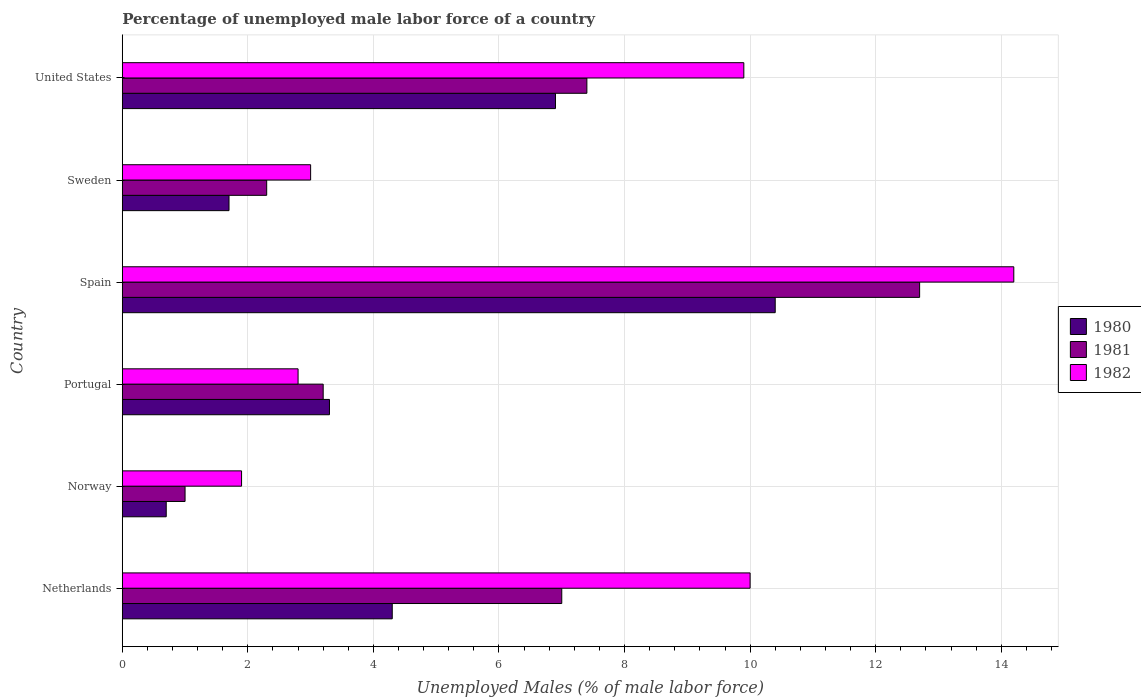How many different coloured bars are there?
Provide a succinct answer. 3. How many groups of bars are there?
Give a very brief answer. 6. Are the number of bars per tick equal to the number of legend labels?
Ensure brevity in your answer.  Yes. What is the percentage of unemployed male labor force in 1981 in Norway?
Ensure brevity in your answer.  1. Across all countries, what is the maximum percentage of unemployed male labor force in 1981?
Offer a very short reply. 12.7. Across all countries, what is the minimum percentage of unemployed male labor force in 1982?
Provide a succinct answer. 1.9. In which country was the percentage of unemployed male labor force in 1980 maximum?
Your response must be concise. Spain. What is the total percentage of unemployed male labor force in 1982 in the graph?
Your response must be concise. 41.8. What is the difference between the percentage of unemployed male labor force in 1980 in Netherlands and that in United States?
Give a very brief answer. -2.6. What is the difference between the percentage of unemployed male labor force in 1982 in Netherlands and the percentage of unemployed male labor force in 1981 in United States?
Your response must be concise. 2.6. What is the average percentage of unemployed male labor force in 1982 per country?
Provide a short and direct response. 6.97. What is the difference between the percentage of unemployed male labor force in 1981 and percentage of unemployed male labor force in 1980 in Spain?
Your answer should be very brief. 2.3. In how many countries, is the percentage of unemployed male labor force in 1982 greater than 10 %?
Your answer should be compact. 1. What is the ratio of the percentage of unemployed male labor force in 1981 in Netherlands to that in Portugal?
Provide a succinct answer. 2.19. Is the percentage of unemployed male labor force in 1980 in Netherlands less than that in United States?
Your response must be concise. Yes. Is the difference between the percentage of unemployed male labor force in 1981 in Netherlands and Portugal greater than the difference between the percentage of unemployed male labor force in 1980 in Netherlands and Portugal?
Keep it short and to the point. Yes. What is the difference between the highest and the second highest percentage of unemployed male labor force in 1982?
Ensure brevity in your answer.  4.2. What is the difference between the highest and the lowest percentage of unemployed male labor force in 1982?
Offer a terse response. 12.3. Is the sum of the percentage of unemployed male labor force in 1981 in Netherlands and United States greater than the maximum percentage of unemployed male labor force in 1982 across all countries?
Give a very brief answer. Yes. Is it the case that in every country, the sum of the percentage of unemployed male labor force in 1981 and percentage of unemployed male labor force in 1980 is greater than the percentage of unemployed male labor force in 1982?
Make the answer very short. No. How many bars are there?
Give a very brief answer. 18. How many countries are there in the graph?
Offer a terse response. 6. Does the graph contain any zero values?
Make the answer very short. No. Where does the legend appear in the graph?
Make the answer very short. Center right. How many legend labels are there?
Your response must be concise. 3. What is the title of the graph?
Provide a short and direct response. Percentage of unemployed male labor force of a country. Does "1990" appear as one of the legend labels in the graph?
Give a very brief answer. No. What is the label or title of the X-axis?
Your answer should be very brief. Unemployed Males (% of male labor force). What is the label or title of the Y-axis?
Your answer should be compact. Country. What is the Unemployed Males (% of male labor force) of 1980 in Netherlands?
Offer a terse response. 4.3. What is the Unemployed Males (% of male labor force) in 1981 in Netherlands?
Give a very brief answer. 7. What is the Unemployed Males (% of male labor force) in 1982 in Netherlands?
Your answer should be compact. 10. What is the Unemployed Males (% of male labor force) in 1980 in Norway?
Make the answer very short. 0.7. What is the Unemployed Males (% of male labor force) of 1982 in Norway?
Ensure brevity in your answer.  1.9. What is the Unemployed Males (% of male labor force) of 1980 in Portugal?
Provide a short and direct response. 3.3. What is the Unemployed Males (% of male labor force) of 1981 in Portugal?
Your answer should be compact. 3.2. What is the Unemployed Males (% of male labor force) in 1982 in Portugal?
Make the answer very short. 2.8. What is the Unemployed Males (% of male labor force) of 1980 in Spain?
Make the answer very short. 10.4. What is the Unemployed Males (% of male labor force) in 1981 in Spain?
Ensure brevity in your answer.  12.7. What is the Unemployed Males (% of male labor force) in 1982 in Spain?
Provide a short and direct response. 14.2. What is the Unemployed Males (% of male labor force) in 1980 in Sweden?
Keep it short and to the point. 1.7. What is the Unemployed Males (% of male labor force) in 1981 in Sweden?
Offer a terse response. 2.3. What is the Unemployed Males (% of male labor force) in 1982 in Sweden?
Provide a short and direct response. 3. What is the Unemployed Males (% of male labor force) in 1980 in United States?
Provide a short and direct response. 6.9. What is the Unemployed Males (% of male labor force) of 1981 in United States?
Make the answer very short. 7.4. What is the Unemployed Males (% of male labor force) of 1982 in United States?
Offer a very short reply. 9.9. Across all countries, what is the maximum Unemployed Males (% of male labor force) in 1980?
Offer a very short reply. 10.4. Across all countries, what is the maximum Unemployed Males (% of male labor force) of 1981?
Provide a short and direct response. 12.7. Across all countries, what is the maximum Unemployed Males (% of male labor force) of 1982?
Your answer should be compact. 14.2. Across all countries, what is the minimum Unemployed Males (% of male labor force) of 1980?
Your answer should be very brief. 0.7. Across all countries, what is the minimum Unemployed Males (% of male labor force) in 1982?
Your response must be concise. 1.9. What is the total Unemployed Males (% of male labor force) in 1980 in the graph?
Your answer should be very brief. 27.3. What is the total Unemployed Males (% of male labor force) in 1981 in the graph?
Keep it short and to the point. 33.6. What is the total Unemployed Males (% of male labor force) of 1982 in the graph?
Ensure brevity in your answer.  41.8. What is the difference between the Unemployed Males (% of male labor force) of 1982 in Netherlands and that in Portugal?
Your answer should be compact. 7.2. What is the difference between the Unemployed Males (% of male labor force) in 1980 in Netherlands and that in United States?
Provide a short and direct response. -2.6. What is the difference between the Unemployed Males (% of male labor force) of 1982 in Netherlands and that in United States?
Your answer should be very brief. 0.1. What is the difference between the Unemployed Males (% of male labor force) of 1980 in Norway and that in Portugal?
Provide a succinct answer. -2.6. What is the difference between the Unemployed Males (% of male labor force) of 1981 in Norway and that in Portugal?
Offer a very short reply. -2.2. What is the difference between the Unemployed Males (% of male labor force) of 1982 in Norway and that in Portugal?
Make the answer very short. -0.9. What is the difference between the Unemployed Males (% of male labor force) of 1982 in Norway and that in Spain?
Offer a terse response. -12.3. What is the difference between the Unemployed Males (% of male labor force) of 1980 in Norway and that in Sweden?
Keep it short and to the point. -1. What is the difference between the Unemployed Males (% of male labor force) in 1980 in Norway and that in United States?
Provide a short and direct response. -6.2. What is the difference between the Unemployed Males (% of male labor force) in 1981 in Norway and that in United States?
Keep it short and to the point. -6.4. What is the difference between the Unemployed Males (% of male labor force) of 1982 in Portugal and that in Spain?
Give a very brief answer. -11.4. What is the difference between the Unemployed Males (% of male labor force) in 1980 in Portugal and that in Sweden?
Your answer should be compact. 1.6. What is the difference between the Unemployed Males (% of male labor force) of 1982 in Portugal and that in Sweden?
Provide a short and direct response. -0.2. What is the difference between the Unemployed Males (% of male labor force) of 1980 in Portugal and that in United States?
Provide a short and direct response. -3.6. What is the difference between the Unemployed Males (% of male labor force) in 1981 in Portugal and that in United States?
Your answer should be compact. -4.2. What is the difference between the Unemployed Males (% of male labor force) of 1981 in Spain and that in Sweden?
Your answer should be compact. 10.4. What is the difference between the Unemployed Males (% of male labor force) in 1982 in Spain and that in Sweden?
Make the answer very short. 11.2. What is the difference between the Unemployed Males (% of male labor force) in 1982 in Spain and that in United States?
Your answer should be very brief. 4.3. What is the difference between the Unemployed Males (% of male labor force) of 1981 in Sweden and that in United States?
Give a very brief answer. -5.1. What is the difference between the Unemployed Males (% of male labor force) of 1982 in Sweden and that in United States?
Offer a very short reply. -6.9. What is the difference between the Unemployed Males (% of male labor force) in 1980 in Netherlands and the Unemployed Males (% of male labor force) in 1981 in Norway?
Offer a very short reply. 3.3. What is the difference between the Unemployed Males (% of male labor force) in 1981 in Netherlands and the Unemployed Males (% of male labor force) in 1982 in Norway?
Provide a short and direct response. 5.1. What is the difference between the Unemployed Males (% of male labor force) in 1980 in Netherlands and the Unemployed Males (% of male labor force) in 1982 in Portugal?
Offer a very short reply. 1.5. What is the difference between the Unemployed Males (% of male labor force) in 1981 in Netherlands and the Unemployed Males (% of male labor force) in 1982 in Portugal?
Give a very brief answer. 4.2. What is the difference between the Unemployed Males (% of male labor force) of 1980 in Netherlands and the Unemployed Males (% of male labor force) of 1981 in Sweden?
Make the answer very short. 2. What is the difference between the Unemployed Males (% of male labor force) of 1981 in Netherlands and the Unemployed Males (% of male labor force) of 1982 in Sweden?
Keep it short and to the point. 4. What is the difference between the Unemployed Males (% of male labor force) in 1980 in Netherlands and the Unemployed Males (% of male labor force) in 1981 in United States?
Your answer should be compact. -3.1. What is the difference between the Unemployed Males (% of male labor force) of 1980 in Netherlands and the Unemployed Males (% of male labor force) of 1982 in United States?
Your answer should be compact. -5.6. What is the difference between the Unemployed Males (% of male labor force) of 1980 in Norway and the Unemployed Males (% of male labor force) of 1982 in Portugal?
Your response must be concise. -2.1. What is the difference between the Unemployed Males (% of male labor force) in 1981 in Norway and the Unemployed Males (% of male labor force) in 1982 in Portugal?
Your answer should be compact. -1.8. What is the difference between the Unemployed Males (% of male labor force) in 1980 in Norway and the Unemployed Males (% of male labor force) in 1981 in Spain?
Ensure brevity in your answer.  -12. What is the difference between the Unemployed Males (% of male labor force) in 1980 in Norway and the Unemployed Males (% of male labor force) in 1982 in Spain?
Provide a succinct answer. -13.5. What is the difference between the Unemployed Males (% of male labor force) of 1980 in Norway and the Unemployed Males (% of male labor force) of 1982 in Sweden?
Provide a short and direct response. -2.3. What is the difference between the Unemployed Males (% of male labor force) of 1981 in Norway and the Unemployed Males (% of male labor force) of 1982 in Sweden?
Offer a terse response. -2. What is the difference between the Unemployed Males (% of male labor force) in 1980 in Norway and the Unemployed Males (% of male labor force) in 1981 in United States?
Offer a very short reply. -6.7. What is the difference between the Unemployed Males (% of male labor force) of 1980 in Norway and the Unemployed Males (% of male labor force) of 1982 in United States?
Give a very brief answer. -9.2. What is the difference between the Unemployed Males (% of male labor force) in 1981 in Norway and the Unemployed Males (% of male labor force) in 1982 in United States?
Keep it short and to the point. -8.9. What is the difference between the Unemployed Males (% of male labor force) in 1980 in Portugal and the Unemployed Males (% of male labor force) in 1981 in Spain?
Your answer should be very brief. -9.4. What is the difference between the Unemployed Males (% of male labor force) in 1980 in Portugal and the Unemployed Males (% of male labor force) in 1981 in Sweden?
Your answer should be very brief. 1. What is the difference between the Unemployed Males (% of male labor force) of 1980 in Portugal and the Unemployed Males (% of male labor force) of 1982 in Sweden?
Offer a terse response. 0.3. What is the difference between the Unemployed Males (% of male labor force) of 1980 in Portugal and the Unemployed Males (% of male labor force) of 1981 in United States?
Offer a very short reply. -4.1. What is the difference between the Unemployed Males (% of male labor force) of 1980 in Portugal and the Unemployed Males (% of male labor force) of 1982 in United States?
Your answer should be very brief. -6.6. What is the difference between the Unemployed Males (% of male labor force) in 1980 in Spain and the Unemployed Males (% of male labor force) in 1982 in Sweden?
Offer a very short reply. 7.4. What is the difference between the Unemployed Males (% of male labor force) of 1981 in Spain and the Unemployed Males (% of male labor force) of 1982 in Sweden?
Provide a succinct answer. 9.7. What is the difference between the Unemployed Males (% of male labor force) in 1980 in Spain and the Unemployed Males (% of male labor force) in 1981 in United States?
Provide a succinct answer. 3. What is the difference between the Unemployed Males (% of male labor force) in 1980 in Sweden and the Unemployed Males (% of male labor force) in 1981 in United States?
Your response must be concise. -5.7. What is the average Unemployed Males (% of male labor force) in 1980 per country?
Provide a short and direct response. 4.55. What is the average Unemployed Males (% of male labor force) of 1981 per country?
Provide a short and direct response. 5.6. What is the average Unemployed Males (% of male labor force) of 1982 per country?
Give a very brief answer. 6.97. What is the difference between the Unemployed Males (% of male labor force) in 1980 and Unemployed Males (% of male labor force) in 1982 in Netherlands?
Offer a very short reply. -5.7. What is the difference between the Unemployed Males (% of male labor force) of 1980 and Unemployed Males (% of male labor force) of 1981 in Norway?
Provide a short and direct response. -0.3. What is the difference between the Unemployed Males (% of male labor force) of 1980 and Unemployed Males (% of male labor force) of 1982 in Portugal?
Ensure brevity in your answer.  0.5. What is the difference between the Unemployed Males (% of male labor force) of 1980 and Unemployed Males (% of male labor force) of 1981 in Spain?
Ensure brevity in your answer.  -2.3. What is the difference between the Unemployed Males (% of male labor force) of 1980 and Unemployed Males (% of male labor force) of 1982 in Spain?
Give a very brief answer. -3.8. What is the difference between the Unemployed Males (% of male labor force) of 1980 and Unemployed Males (% of male labor force) of 1981 in Sweden?
Make the answer very short. -0.6. What is the difference between the Unemployed Males (% of male labor force) in 1980 and Unemployed Males (% of male labor force) in 1982 in Sweden?
Give a very brief answer. -1.3. What is the difference between the Unemployed Males (% of male labor force) of 1980 and Unemployed Males (% of male labor force) of 1982 in United States?
Ensure brevity in your answer.  -3. What is the difference between the Unemployed Males (% of male labor force) in 1981 and Unemployed Males (% of male labor force) in 1982 in United States?
Provide a short and direct response. -2.5. What is the ratio of the Unemployed Males (% of male labor force) in 1980 in Netherlands to that in Norway?
Your answer should be compact. 6.14. What is the ratio of the Unemployed Males (% of male labor force) of 1981 in Netherlands to that in Norway?
Keep it short and to the point. 7. What is the ratio of the Unemployed Males (% of male labor force) of 1982 in Netherlands to that in Norway?
Keep it short and to the point. 5.26. What is the ratio of the Unemployed Males (% of male labor force) of 1980 in Netherlands to that in Portugal?
Offer a very short reply. 1.3. What is the ratio of the Unemployed Males (% of male labor force) of 1981 in Netherlands to that in Portugal?
Give a very brief answer. 2.19. What is the ratio of the Unemployed Males (% of male labor force) in 1982 in Netherlands to that in Portugal?
Make the answer very short. 3.57. What is the ratio of the Unemployed Males (% of male labor force) in 1980 in Netherlands to that in Spain?
Your response must be concise. 0.41. What is the ratio of the Unemployed Males (% of male labor force) in 1981 in Netherlands to that in Spain?
Your answer should be very brief. 0.55. What is the ratio of the Unemployed Males (% of male labor force) of 1982 in Netherlands to that in Spain?
Your answer should be compact. 0.7. What is the ratio of the Unemployed Males (% of male labor force) of 1980 in Netherlands to that in Sweden?
Give a very brief answer. 2.53. What is the ratio of the Unemployed Males (% of male labor force) of 1981 in Netherlands to that in Sweden?
Your answer should be compact. 3.04. What is the ratio of the Unemployed Males (% of male labor force) of 1980 in Netherlands to that in United States?
Give a very brief answer. 0.62. What is the ratio of the Unemployed Males (% of male labor force) of 1981 in Netherlands to that in United States?
Your response must be concise. 0.95. What is the ratio of the Unemployed Males (% of male labor force) of 1982 in Netherlands to that in United States?
Your response must be concise. 1.01. What is the ratio of the Unemployed Males (% of male labor force) in 1980 in Norway to that in Portugal?
Offer a terse response. 0.21. What is the ratio of the Unemployed Males (% of male labor force) of 1981 in Norway to that in Portugal?
Your response must be concise. 0.31. What is the ratio of the Unemployed Males (% of male labor force) in 1982 in Norway to that in Portugal?
Your answer should be very brief. 0.68. What is the ratio of the Unemployed Males (% of male labor force) of 1980 in Norway to that in Spain?
Provide a succinct answer. 0.07. What is the ratio of the Unemployed Males (% of male labor force) in 1981 in Norway to that in Spain?
Your answer should be very brief. 0.08. What is the ratio of the Unemployed Males (% of male labor force) in 1982 in Norway to that in Spain?
Provide a succinct answer. 0.13. What is the ratio of the Unemployed Males (% of male labor force) in 1980 in Norway to that in Sweden?
Provide a short and direct response. 0.41. What is the ratio of the Unemployed Males (% of male labor force) in 1981 in Norway to that in Sweden?
Offer a terse response. 0.43. What is the ratio of the Unemployed Males (% of male labor force) of 1982 in Norway to that in Sweden?
Offer a very short reply. 0.63. What is the ratio of the Unemployed Males (% of male labor force) of 1980 in Norway to that in United States?
Keep it short and to the point. 0.1. What is the ratio of the Unemployed Males (% of male labor force) of 1981 in Norway to that in United States?
Your answer should be compact. 0.14. What is the ratio of the Unemployed Males (% of male labor force) in 1982 in Norway to that in United States?
Your response must be concise. 0.19. What is the ratio of the Unemployed Males (% of male labor force) in 1980 in Portugal to that in Spain?
Provide a succinct answer. 0.32. What is the ratio of the Unemployed Males (% of male labor force) in 1981 in Portugal to that in Spain?
Provide a short and direct response. 0.25. What is the ratio of the Unemployed Males (% of male labor force) of 1982 in Portugal to that in Spain?
Provide a succinct answer. 0.2. What is the ratio of the Unemployed Males (% of male labor force) of 1980 in Portugal to that in Sweden?
Your answer should be very brief. 1.94. What is the ratio of the Unemployed Males (% of male labor force) of 1981 in Portugal to that in Sweden?
Your answer should be very brief. 1.39. What is the ratio of the Unemployed Males (% of male labor force) in 1982 in Portugal to that in Sweden?
Provide a short and direct response. 0.93. What is the ratio of the Unemployed Males (% of male labor force) in 1980 in Portugal to that in United States?
Ensure brevity in your answer.  0.48. What is the ratio of the Unemployed Males (% of male labor force) in 1981 in Portugal to that in United States?
Make the answer very short. 0.43. What is the ratio of the Unemployed Males (% of male labor force) of 1982 in Portugal to that in United States?
Your response must be concise. 0.28. What is the ratio of the Unemployed Males (% of male labor force) of 1980 in Spain to that in Sweden?
Provide a short and direct response. 6.12. What is the ratio of the Unemployed Males (% of male labor force) in 1981 in Spain to that in Sweden?
Make the answer very short. 5.52. What is the ratio of the Unemployed Males (% of male labor force) of 1982 in Spain to that in Sweden?
Your answer should be very brief. 4.73. What is the ratio of the Unemployed Males (% of male labor force) of 1980 in Spain to that in United States?
Offer a very short reply. 1.51. What is the ratio of the Unemployed Males (% of male labor force) in 1981 in Spain to that in United States?
Provide a succinct answer. 1.72. What is the ratio of the Unemployed Males (% of male labor force) in 1982 in Spain to that in United States?
Keep it short and to the point. 1.43. What is the ratio of the Unemployed Males (% of male labor force) in 1980 in Sweden to that in United States?
Ensure brevity in your answer.  0.25. What is the ratio of the Unemployed Males (% of male labor force) in 1981 in Sweden to that in United States?
Keep it short and to the point. 0.31. What is the ratio of the Unemployed Males (% of male labor force) of 1982 in Sweden to that in United States?
Offer a very short reply. 0.3. What is the difference between the highest and the second highest Unemployed Males (% of male labor force) of 1980?
Your response must be concise. 3.5. What is the difference between the highest and the lowest Unemployed Males (% of male labor force) of 1981?
Offer a very short reply. 11.7. What is the difference between the highest and the lowest Unemployed Males (% of male labor force) in 1982?
Provide a short and direct response. 12.3. 